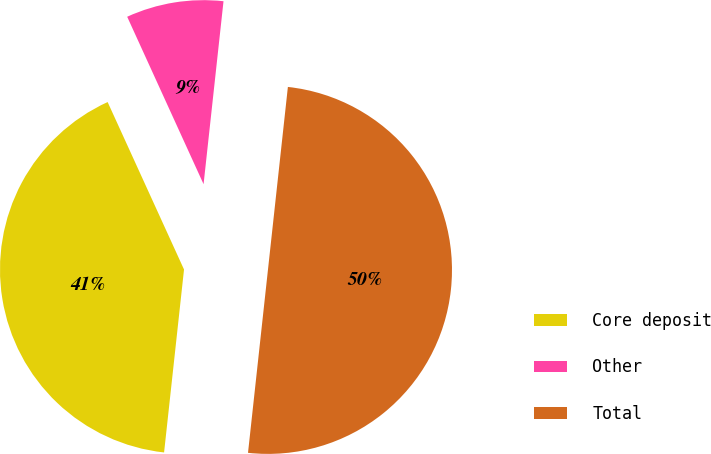<chart> <loc_0><loc_0><loc_500><loc_500><pie_chart><fcel>Core deposit<fcel>Other<fcel>Total<nl><fcel>41.46%<fcel>8.54%<fcel>50.0%<nl></chart> 